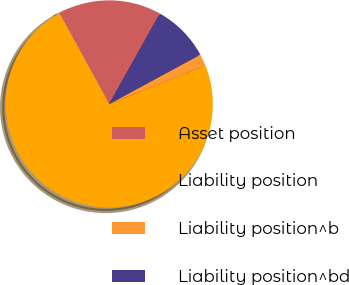Convert chart. <chart><loc_0><loc_0><loc_500><loc_500><pie_chart><fcel>Asset position<fcel>Liability position<fcel>Liability position^b<fcel>Liability position^bd<nl><fcel>16.1%<fcel>73.06%<fcel>1.86%<fcel>8.98%<nl></chart> 